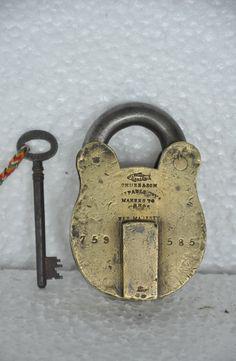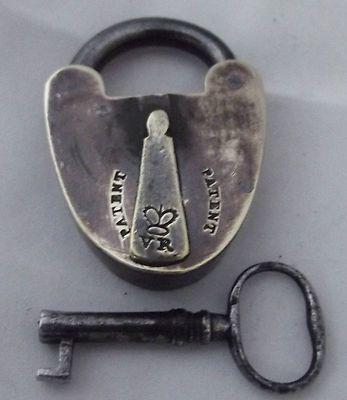The first image is the image on the left, the second image is the image on the right. Evaluate the accuracy of this statement regarding the images: "There are no less than two keys inserted into padlocks". Is it true? Answer yes or no. No. The first image is the image on the left, the second image is the image on the right. Considering the images on both sides, is "there are locks with the keys inserted in the bottom" valid? Answer yes or no. No. 